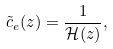<formula> <loc_0><loc_0><loc_500><loc_500>\tilde { c } _ { e } ( z ) = \frac { 1 } { \mathcal { H } ( z ) } ,</formula> 